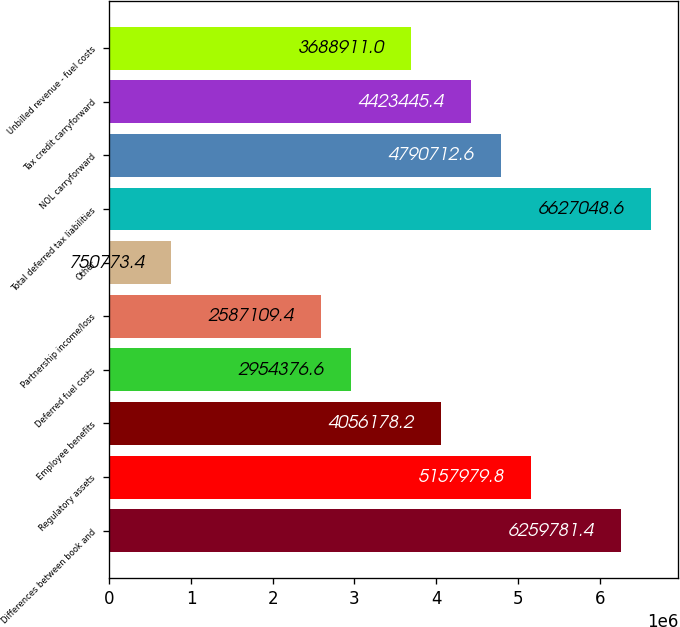Convert chart to OTSL. <chart><loc_0><loc_0><loc_500><loc_500><bar_chart><fcel>Differences between book and<fcel>Regulatory assets<fcel>Employee benefits<fcel>Deferred fuel costs<fcel>Partnership income/loss<fcel>Other<fcel>Total deferred tax liabilities<fcel>NOL carryforward<fcel>Tax credit carryforward<fcel>Unbilled revenue - fuel costs<nl><fcel>6.25978e+06<fcel>5.15798e+06<fcel>4.05618e+06<fcel>2.95438e+06<fcel>2.58711e+06<fcel>750773<fcel>6.62705e+06<fcel>4.79071e+06<fcel>4.42345e+06<fcel>3.68891e+06<nl></chart> 